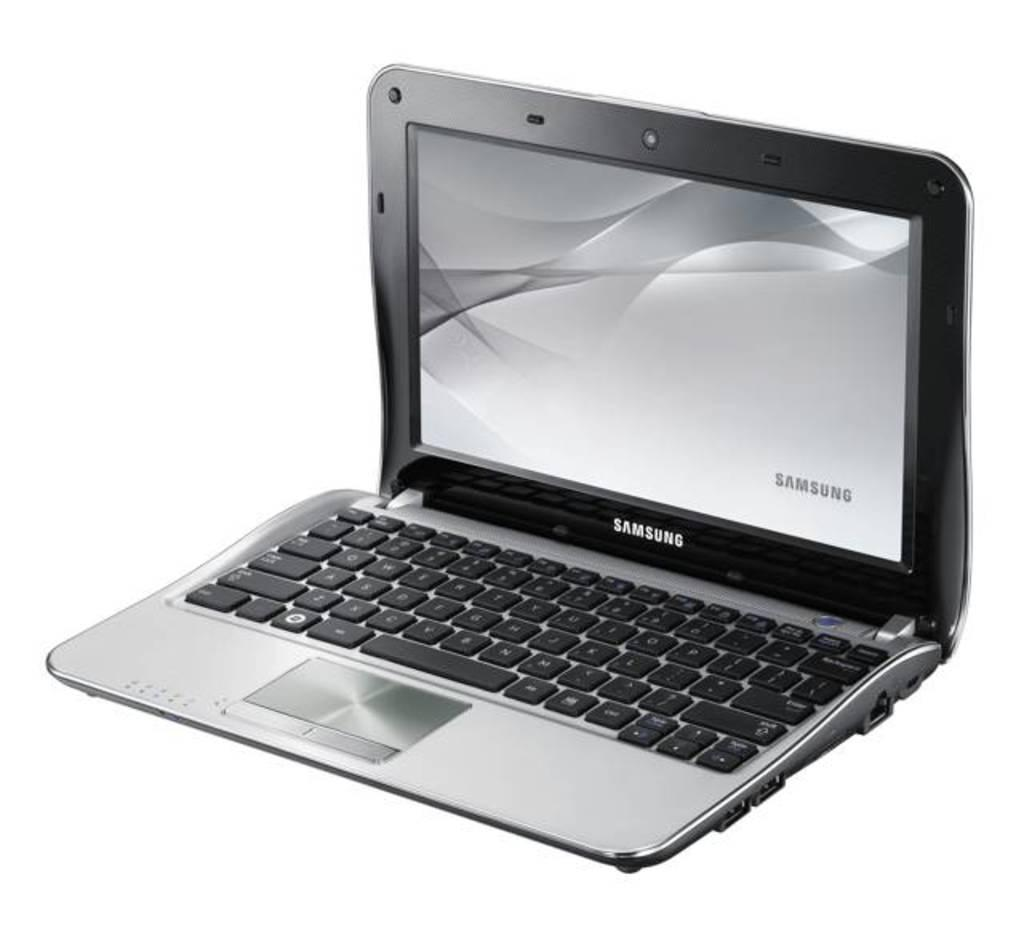Provide a one-sentence caption for the provided image. A gray and silver Samsung laptop opened with the screen displaying Samsung. 